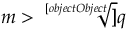Convert formula to latex. <formula><loc_0><loc_0><loc_500><loc_500>m > { \sqrt { [ } [ o b j e c t O b j e c t ] ] { q } }</formula> 